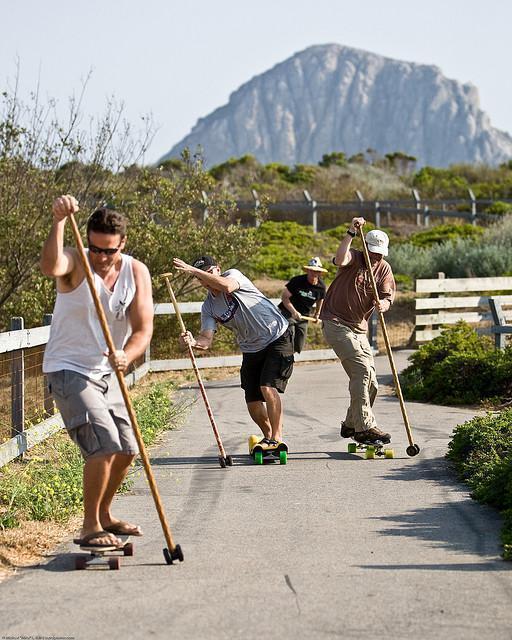What are the men doing with the large wooden poles?
From the following set of four choices, select the accurate answer to respond to the question.
Options: Exercising, fighting, land paddling, jousting. Land paddling. 